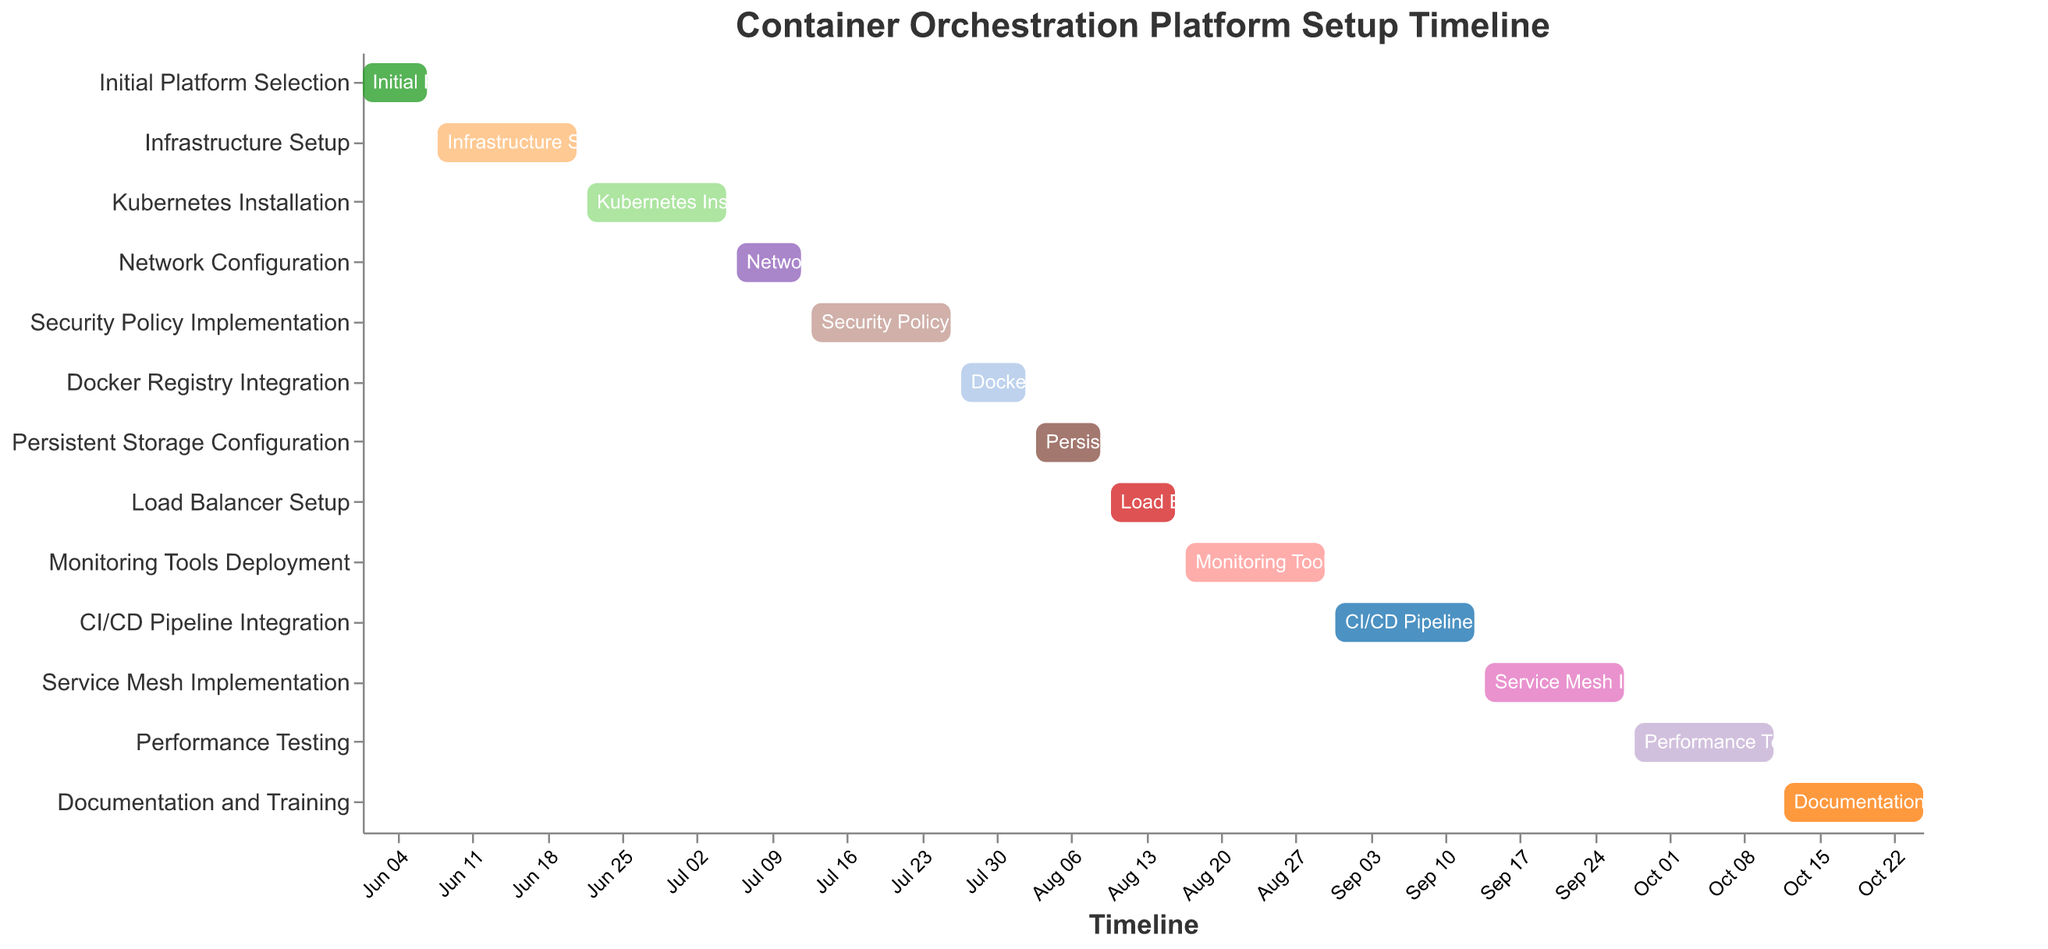What is the title of the Gantt chart? The title is located at the top of the chart and reads "Container Orchestration Platform Setup Timeline" as per the given specifications in the code.
Answer: Container Orchestration Platform Setup Timeline When does the Infrastructure Setup task start and end? By locating the "Infrastructure Setup" task on the Y-axis and tracing its corresponding bar on the X-axis, the start date is June 8, 2023, and the end date is June 21, 2023.
Answer: June 8, 2023 - June 21, 2023 How long does the Kubernetes Installation task last? The "Kubernetes Installation" task bar spans from June 22, 2023, to July 5, 2023, which can be calculated as 14 days in duration, as also confirmed in the data provided.
Answer: 14 days Which task takes place immediately after the Persistent Storage Configuration task? The "Persistent Storage Configuration" task ends on August 9, 2023. By examining the next task on the timeline, we see that the "Load Balancer Setup" task starts on August 10, 2023.
Answer: Load Balancer Setup Which task has the shortest duration? By examining the bars' lengths and cross-referencing the duration data, the tasks "Initial Platform Selection", "Network Configuration", "Docker Registry Integration", "Persistent Storage Configuration", and "Load Balancer Setup" each span 7 days, making them the shortest duration tasks.
Answer: Initial Platform Selection, Network Configuration, Docker Registry Integration, Persistent Storage Configuration, Load Balancer Setup Which milestone tasks overlap with the Deployment of Monitoring Tools? "Monitoring Tools Deployment" runs from August 17, 2023, to August 30, 2023. "Load Balancer Setup" overlaps on the starting end (ends on August 16, 2023), and "CI/CD Pipeline Integration" overlaps on the other end (starts on August 31, 2023), but there is no direct overlap. Thus, no active task overlaps directly with "Monitoring Tools Deployment."
Answer: None How many tasks are planned to be completed before September 1, 2023? By examining the end dates for each task: "Initial Platform Selection", "Infrastructure Setup", "Kubernetes Installation", "Network Configuration", "Security Policy Implementation", "Docker Registry Integration", "Persistent Storage Configuration", and "Load Balancer Setup" are all finished by August 30, 2023. Therefore, there are 8 tasks completed before September 1, 2023.
Answer: 8 Which tasks span the exact same number of days? Tasks lasting 14 days include "Infrastructure Setup", "Kubernetes Installation", "Security Policy Implementation", "Monitoring Tools Deployment", "CI/CD Pipeline Integration", "Service Mesh Implementation", "Performance Testing", and "Documentation and Training". All these tasks span 14 days each.
Answer: Infrastructure Setup, Kubernetes Installation, Security Policy Implementation, Monitoring Tools Deployment, CI/CD Pipeline Integration, Service Mesh Implementation, Performance Testing, Documentation and Training 